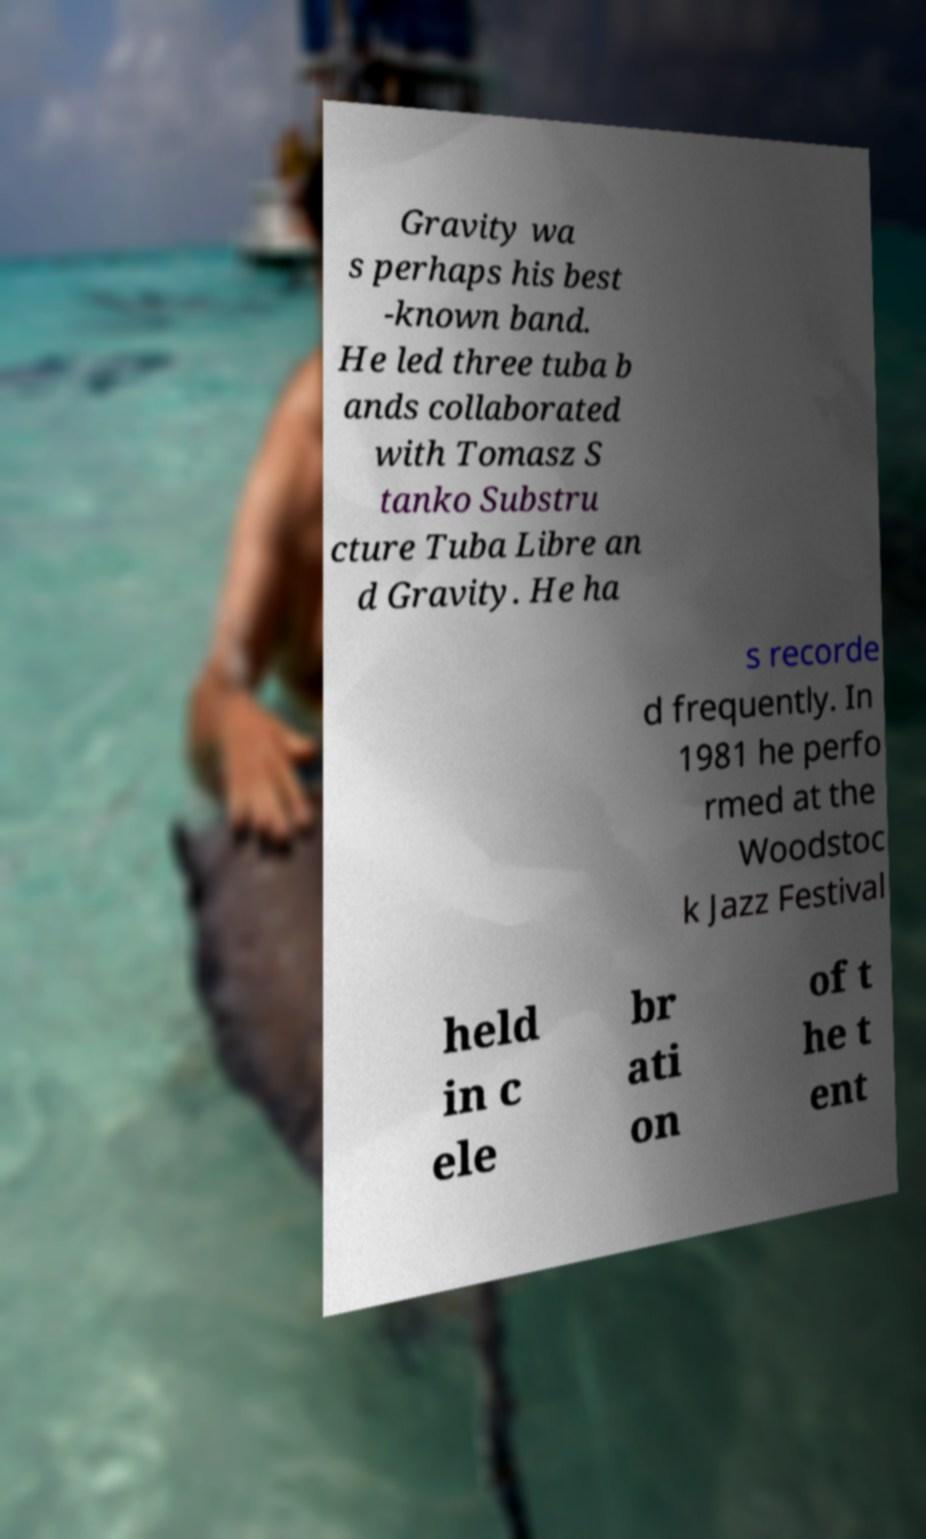Please read and relay the text visible in this image. What does it say? Gravity wa s perhaps his best -known band. He led three tuba b ands collaborated with Tomasz S tanko Substru cture Tuba Libre an d Gravity. He ha s recorde d frequently. In 1981 he perfo rmed at the Woodstoc k Jazz Festival held in c ele br ati on of t he t ent 